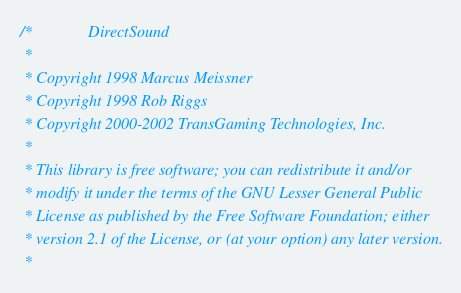<code> <loc_0><loc_0><loc_500><loc_500><_C_>/*  			DirectSound
 *
 * Copyright 1998 Marcus Meissner
 * Copyright 1998 Rob Riggs
 * Copyright 2000-2002 TransGaming Technologies, Inc.
 *
 * This library is free software; you can redistribute it and/or
 * modify it under the terms of the GNU Lesser General Public
 * License as published by the Free Software Foundation; either
 * version 2.1 of the License, or (at your option) any later version.
 *</code> 